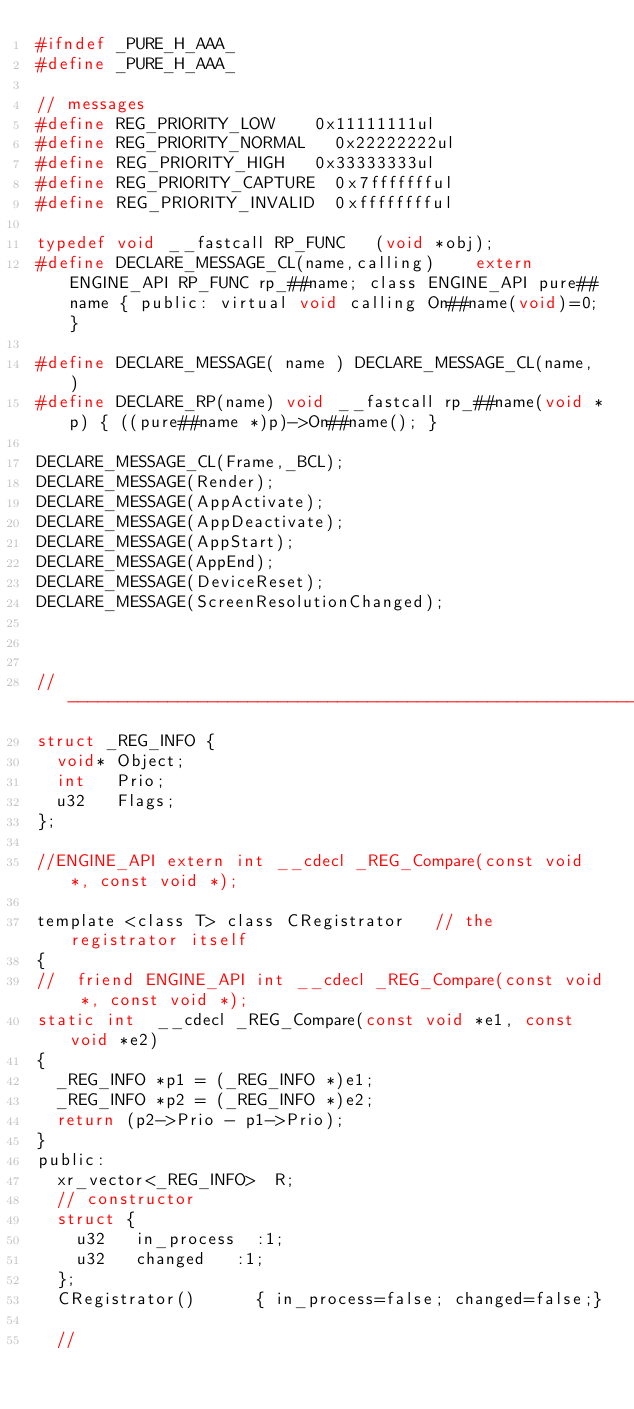Convert code to text. <code><loc_0><loc_0><loc_500><loc_500><_C_>#ifndef _PURE_H_AAA_
#define _PURE_H_AAA_

// messages
#define REG_PRIORITY_LOW		0x11111111ul
#define REG_PRIORITY_NORMAL		0x22222222ul
#define REG_PRIORITY_HIGH		0x33333333ul
#define REG_PRIORITY_CAPTURE	0x7ffffffful
#define REG_PRIORITY_INVALID	0xfffffffful

typedef void __fastcall RP_FUNC		(void *obj);
#define DECLARE_MESSAGE_CL(name,calling)		extern ENGINE_API RP_FUNC rp_##name; class ENGINE_API pure##name { public: virtual void calling On##name(void)=0;	}
	
#define DECLARE_MESSAGE( name )	DECLARE_MESSAGE_CL(name, )
#define DECLARE_RP(name) void __fastcall rp_##name(void *p) { ((pure##name *)p)->On##name(); }

DECLARE_MESSAGE_CL(Frame,_BCL);
DECLARE_MESSAGE(Render);
DECLARE_MESSAGE(AppActivate);
DECLARE_MESSAGE(AppDeactivate);
DECLARE_MESSAGE(AppStart);
DECLARE_MESSAGE(AppEnd);
DECLARE_MESSAGE(DeviceReset);
DECLARE_MESSAGE(ScreenResolutionChanged);



//-----------------------------------------------------------------------------
struct _REG_INFO {
	void*	Object;
	int		Prio;
	u32		Flags;
};

//ENGINE_API extern int	__cdecl	_REG_Compare(const void *, const void *);

template <class T> class CRegistrator		// the registrator itself
{
//	friend ENGINE_API int	__cdecl	_REG_Compare(const void *, const void *);
static int	__cdecl	_REG_Compare(const void *e1, const void *e2)
{
	_REG_INFO *p1 = (_REG_INFO *)e1;
	_REG_INFO *p2 = (_REG_INFO *)e2;
	return (p2->Prio - p1->Prio);
}
public:
	xr_vector<_REG_INFO>	R;
	// constructor
	struct {
		u32		in_process	:1;
		u32		changed		:1;
	};
	CRegistrator()			{ in_process=false; changed=false;}

	//</code> 